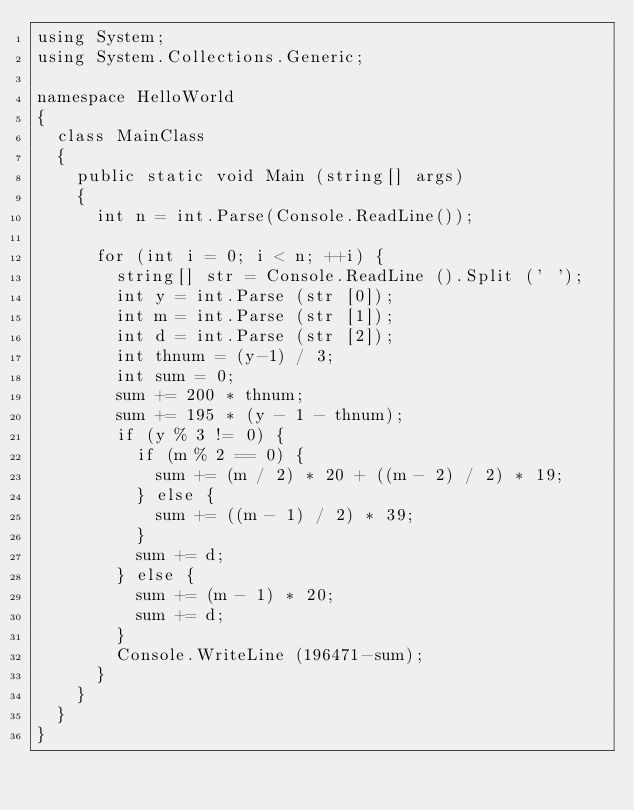Convert code to text. <code><loc_0><loc_0><loc_500><loc_500><_C#_>using System;
using System.Collections.Generic;

namespace HelloWorld
{
	class MainClass
	{
		public static void Main (string[] args)
		{
			int n = int.Parse(Console.ReadLine());

			for (int i = 0; i < n; ++i) {
				string[] str = Console.ReadLine ().Split (' ');
				int y = int.Parse (str [0]);
				int m = int.Parse (str [1]);
				int d = int.Parse (str [2]);
				int thnum = (y-1) / 3;
				int sum = 0;
				sum += 200 * thnum;
				sum += 195 * (y - 1 - thnum);
				if (y % 3 != 0) {
					if (m % 2 == 0) {
						sum += (m / 2) * 20 + ((m - 2) / 2) * 19;
					} else {
						sum += ((m - 1) / 2) * 39;
					}
					sum += d;
				} else {
					sum += (m - 1) * 20;
					sum += d;
				}
				Console.WriteLine (196471-sum);
			}
		}
	}
}

</code> 